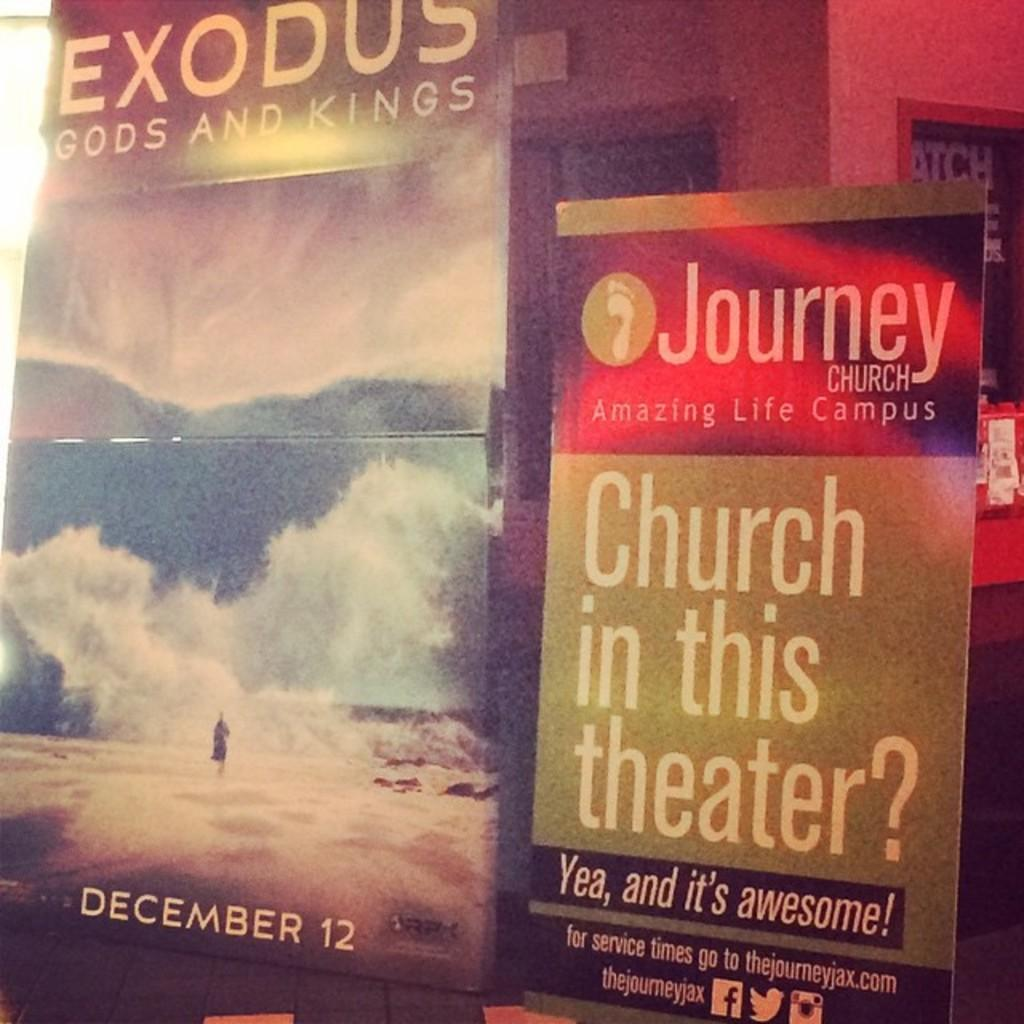Provide a one-sentence caption for the provided image. In a room there is a poster that says Church in this theater. 